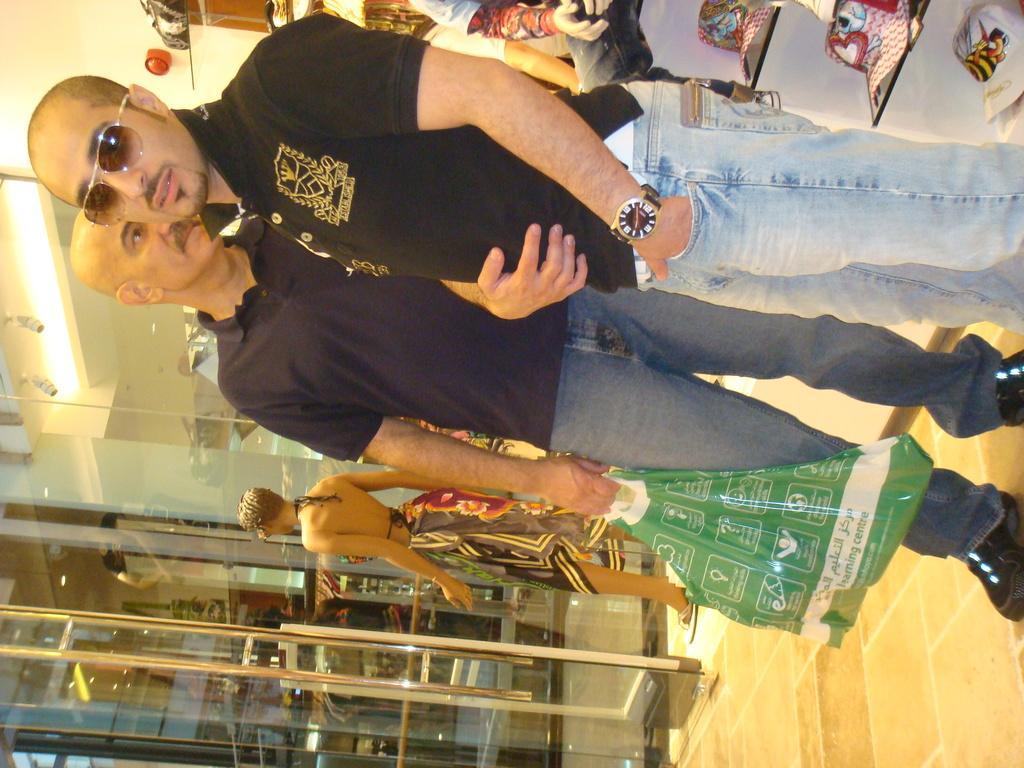Can you describe this image briefly? In this image I can see people among them this man is holding a carry bag in the hand. In the background I can see a glass door, hats in the shelf and other objects. 